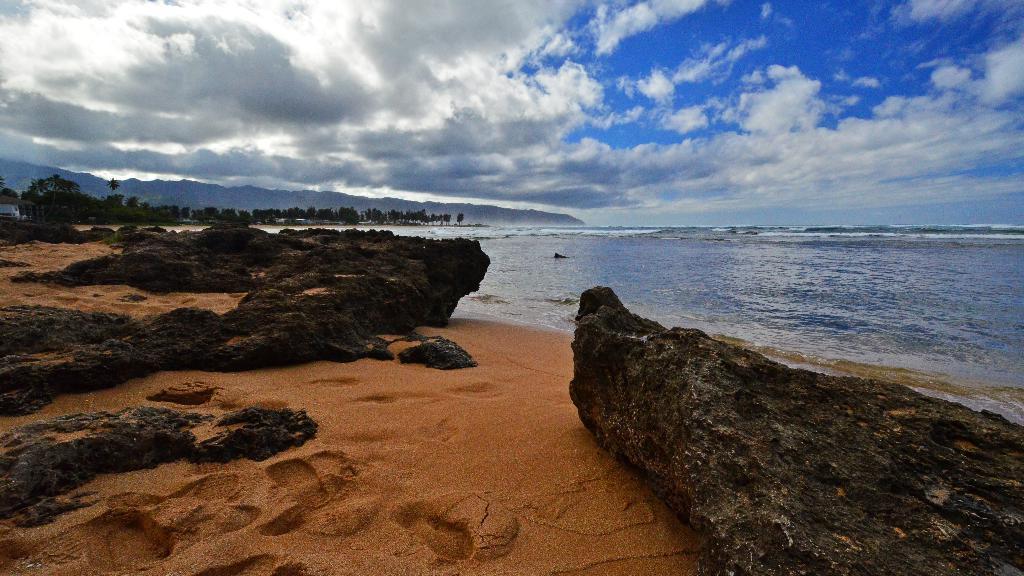How would you summarize this image in a sentence or two? At the bottom of the picture, we see the sand and the rocks. On the right side, we see water and this water might be in the sea. There are trees and hills in the background. At the top, we see the clouds and the sky. This picture might be clicked at the seashore. 